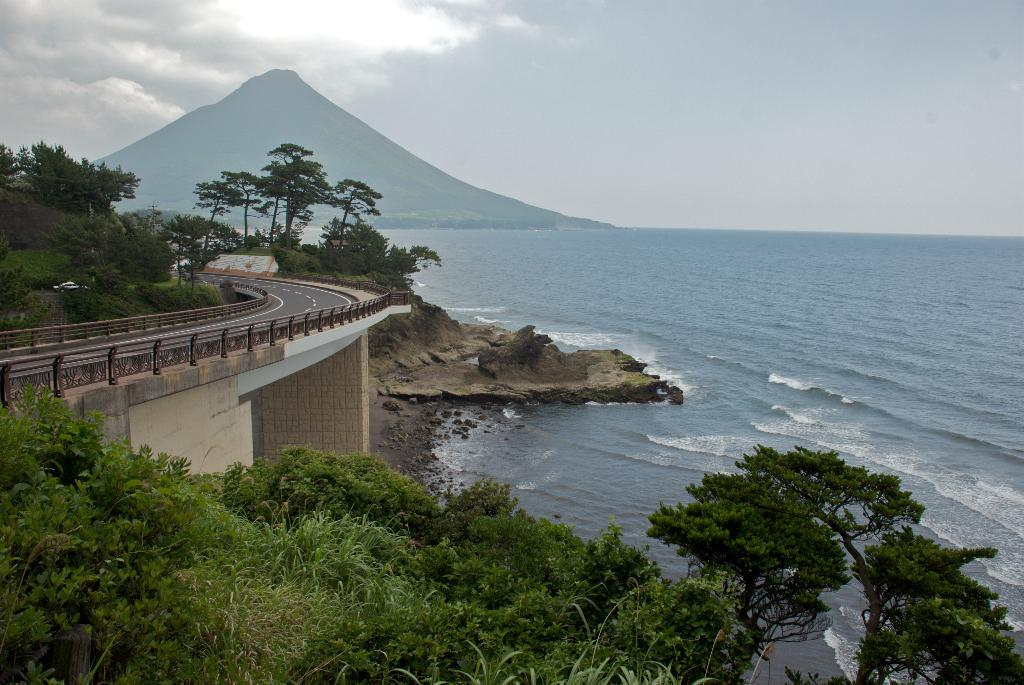What is the condition of the sky in the image? The sky is cloudy in the image. What type of vegetation can be seen in the image? There are trees in the image. What type of structure is present in the image? There is a bridge in the image. What natural feature is visible in the image? There is water visible in the image. What can be seen in the distance in the image? There is a mountain in the distance. What type of hole can be seen in the image? There is no hole present in the image. Can you describe the sofa in the image? There is no sofa present in the image. 